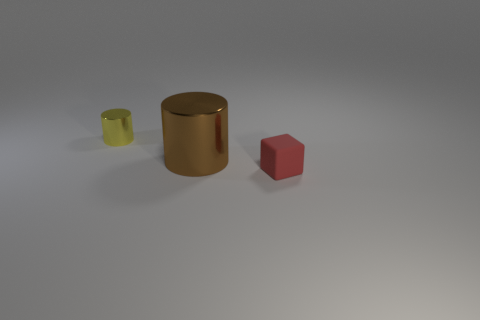Add 3 brown shiny cylinders. How many objects exist? 6 Subtract all blocks. How many objects are left? 2 Subtract all red cylinders. Subtract all purple balls. How many cylinders are left? 2 Subtract all brown metal objects. Subtract all small red matte objects. How many objects are left? 1 Add 2 brown cylinders. How many brown cylinders are left? 3 Add 3 cyan cubes. How many cyan cubes exist? 3 Subtract 0 blue balls. How many objects are left? 3 